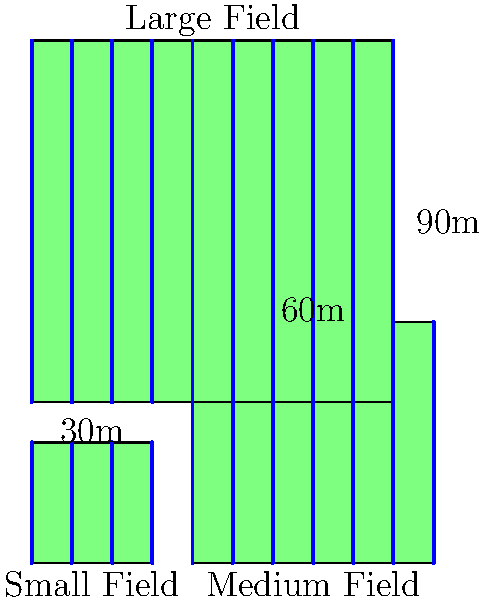As a farmer dealing with varying field sizes, you need to design an efficient irrigation system. The diagram shows three fields of different sizes: small (30m x 30m), medium (60m x 60m), and large (90m x 90m). If the optimal spacing between irrigation lines is 10 meters, what is the total length of irrigation lines needed for all three fields combined? Let's calculate the length of irrigation lines needed for each field:

1. Small field (30m x 30m):
   - Number of lines = 30m ÷ 10m + 1 = 4 lines
   - Length per line = 30m
   - Total length for small field = 4 × 30m = 120m

2. Medium field (60m x 60m):
   - Number of lines = 60m ÷ 10m + 1 = 7 lines
   - Length per line = 60m
   - Total length for medium field = 7 × 60m = 420m

3. Large field (90m x 90m):
   - Number of lines = 90m ÷ 10m + 1 = 10 lines
   - Length per line = 90m
   - Total length for large field = 10 × 90m = 900m

4. Sum up the total length for all fields:
   Total length = Small field + Medium field + Large field
   Total length = 120m + 420m + 900m = 1440m

Therefore, the total length of irrigation lines needed for all three fields combined is 1440 meters.
Answer: 1440 meters 